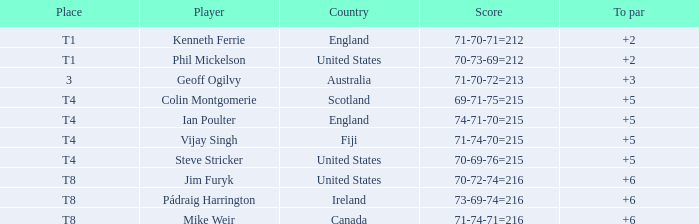What was mike weir's score relative to par? 6.0. 